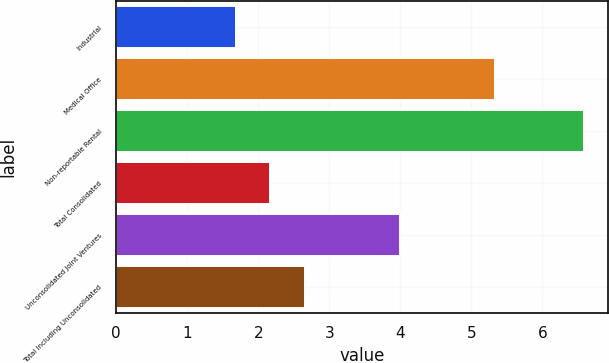Convert chart to OTSL. <chart><loc_0><loc_0><loc_500><loc_500><bar_chart><fcel>Industrial<fcel>Medical Office<fcel>Non-reportable Rental<fcel>Total Consolidated<fcel>Unconsolidated Joint Ventures<fcel>Total Including Unconsolidated<nl><fcel>1.68<fcel>5.34<fcel>6.59<fcel>2.17<fcel>3.99<fcel>2.66<nl></chart> 